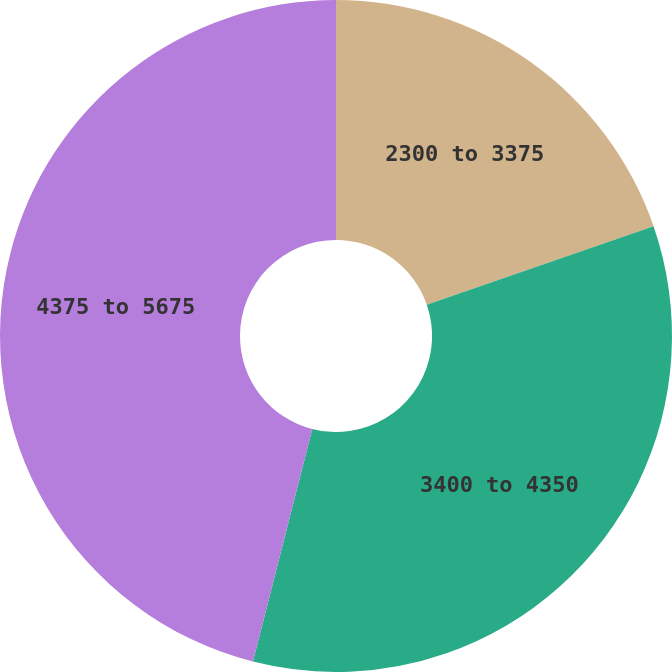Convert chart. <chart><loc_0><loc_0><loc_500><loc_500><pie_chart><fcel>2300 to 3375<fcel>3400 to 4350<fcel>4375 to 5675<nl><fcel>19.7%<fcel>34.27%<fcel>46.02%<nl></chart> 